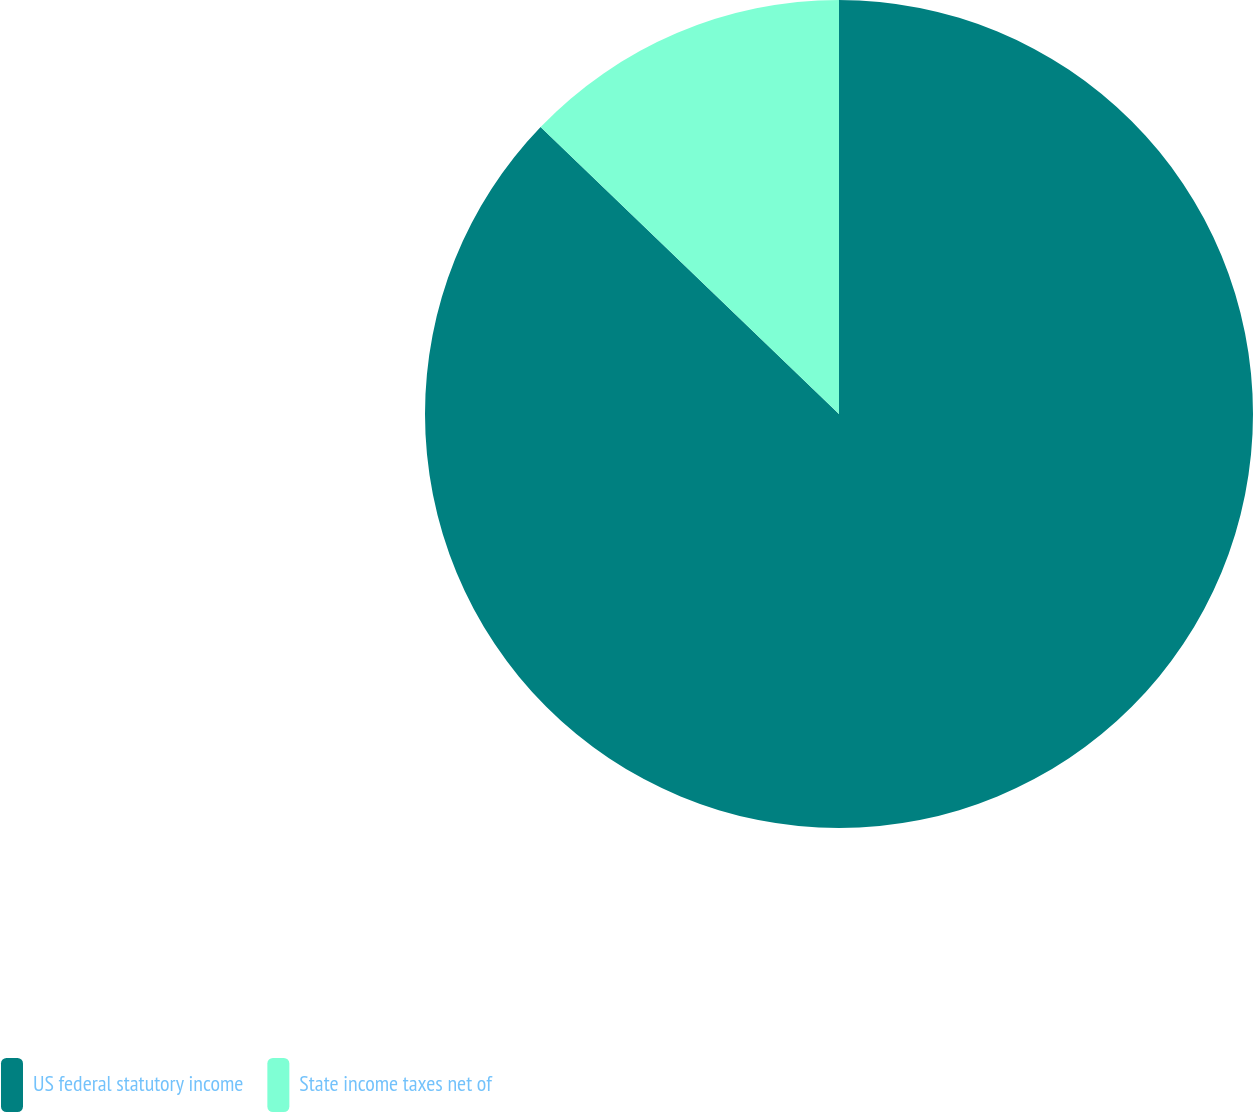Convert chart. <chart><loc_0><loc_0><loc_500><loc_500><pie_chart><fcel>US federal statutory income<fcel>State income taxes net of<nl><fcel>87.19%<fcel>12.81%<nl></chart> 